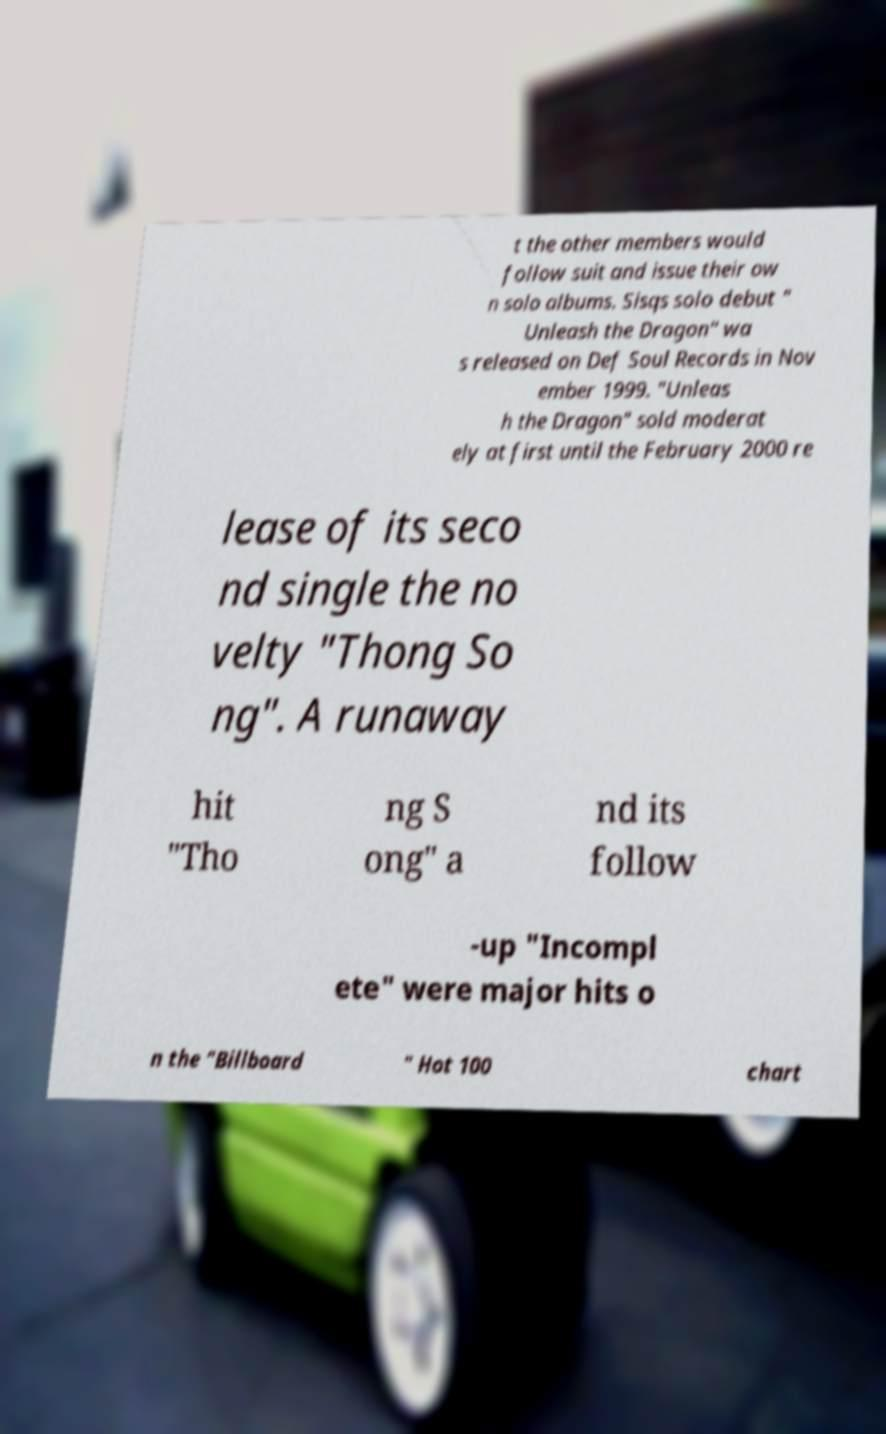Please identify and transcribe the text found in this image. t the other members would follow suit and issue their ow n solo albums. Sisqs solo debut " Unleash the Dragon" wa s released on Def Soul Records in Nov ember 1999. "Unleas h the Dragon" sold moderat ely at first until the February 2000 re lease of its seco nd single the no velty "Thong So ng". A runaway hit "Tho ng S ong" a nd its follow -up "Incompl ete" were major hits o n the "Billboard " Hot 100 chart 